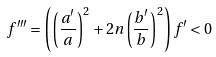<formula> <loc_0><loc_0><loc_500><loc_500>f ^ { \prime \prime \prime } = \left ( \left ( \frac { a ^ { \prime } } { a } \right ) ^ { 2 } + 2 n \left ( \frac { b ^ { \prime } } { b } \right ) ^ { 2 } \right ) f ^ { \prime } < 0</formula> 